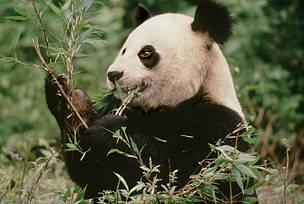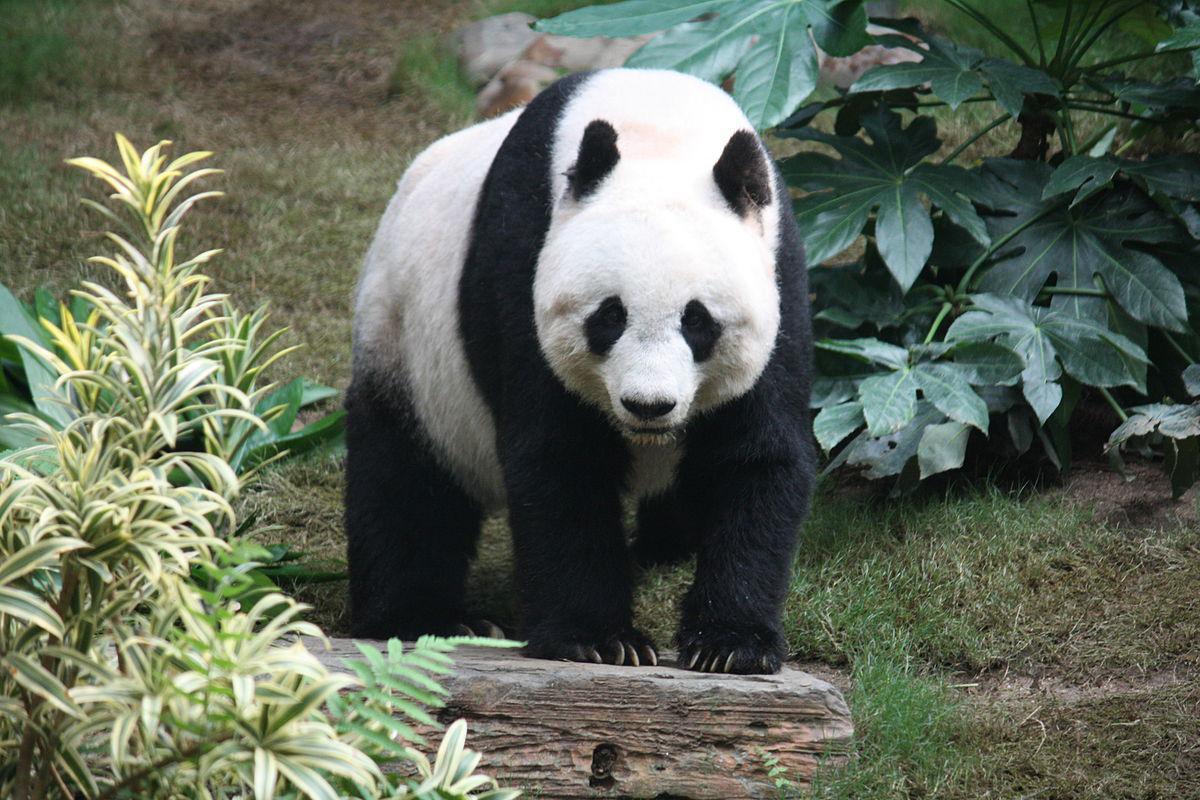The first image is the image on the left, the second image is the image on the right. Considering the images on both sides, is "An image shows one open-mouthed panda clutching a leafless stalk." valid? Answer yes or no. No. 